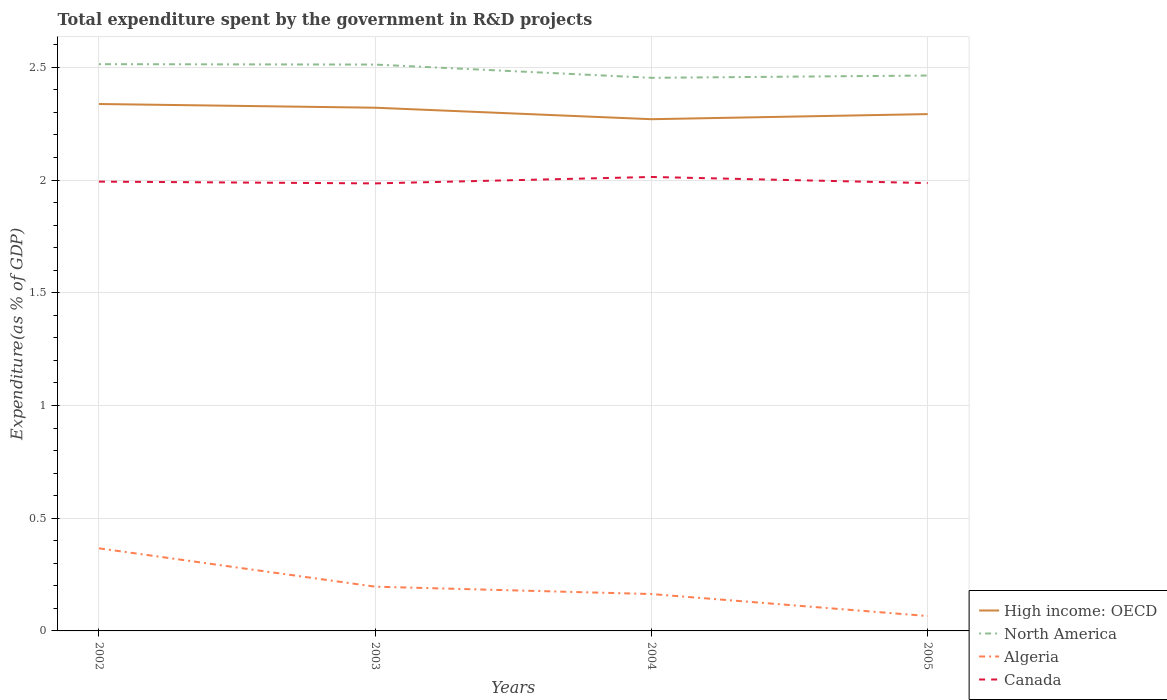How many different coloured lines are there?
Keep it short and to the point. 4. Across all years, what is the maximum total expenditure spent by the government in R&D projects in Canada?
Your answer should be very brief. 1.99. What is the total total expenditure spent by the government in R&D projects in Algeria in the graph?
Provide a short and direct response. 0.3. What is the difference between the highest and the second highest total expenditure spent by the government in R&D projects in Algeria?
Give a very brief answer. 0.3. What is the difference between the highest and the lowest total expenditure spent by the government in R&D projects in Algeria?
Your response must be concise. 1. How many lines are there?
Provide a short and direct response. 4. Where does the legend appear in the graph?
Your response must be concise. Bottom right. What is the title of the graph?
Your answer should be compact. Total expenditure spent by the government in R&D projects. Does "High income" appear as one of the legend labels in the graph?
Keep it short and to the point. No. What is the label or title of the X-axis?
Offer a terse response. Years. What is the label or title of the Y-axis?
Offer a terse response. Expenditure(as % of GDP). What is the Expenditure(as % of GDP) of High income: OECD in 2002?
Your answer should be compact. 2.34. What is the Expenditure(as % of GDP) of North America in 2002?
Your answer should be very brief. 2.51. What is the Expenditure(as % of GDP) in Algeria in 2002?
Offer a terse response. 0.37. What is the Expenditure(as % of GDP) in Canada in 2002?
Keep it short and to the point. 1.99. What is the Expenditure(as % of GDP) in High income: OECD in 2003?
Ensure brevity in your answer.  2.32. What is the Expenditure(as % of GDP) of North America in 2003?
Your answer should be very brief. 2.51. What is the Expenditure(as % of GDP) of Algeria in 2003?
Provide a succinct answer. 0.2. What is the Expenditure(as % of GDP) of Canada in 2003?
Give a very brief answer. 1.99. What is the Expenditure(as % of GDP) in High income: OECD in 2004?
Keep it short and to the point. 2.27. What is the Expenditure(as % of GDP) in North America in 2004?
Your answer should be very brief. 2.45. What is the Expenditure(as % of GDP) of Algeria in 2004?
Offer a terse response. 0.16. What is the Expenditure(as % of GDP) in Canada in 2004?
Your answer should be very brief. 2.01. What is the Expenditure(as % of GDP) in High income: OECD in 2005?
Make the answer very short. 2.29. What is the Expenditure(as % of GDP) of North America in 2005?
Your answer should be compact. 2.46. What is the Expenditure(as % of GDP) in Algeria in 2005?
Provide a succinct answer. 0.07. What is the Expenditure(as % of GDP) of Canada in 2005?
Your answer should be compact. 1.99. Across all years, what is the maximum Expenditure(as % of GDP) of High income: OECD?
Offer a very short reply. 2.34. Across all years, what is the maximum Expenditure(as % of GDP) in North America?
Give a very brief answer. 2.51. Across all years, what is the maximum Expenditure(as % of GDP) in Algeria?
Make the answer very short. 0.37. Across all years, what is the maximum Expenditure(as % of GDP) of Canada?
Keep it short and to the point. 2.01. Across all years, what is the minimum Expenditure(as % of GDP) of High income: OECD?
Your answer should be very brief. 2.27. Across all years, what is the minimum Expenditure(as % of GDP) in North America?
Ensure brevity in your answer.  2.45. Across all years, what is the minimum Expenditure(as % of GDP) in Algeria?
Give a very brief answer. 0.07. Across all years, what is the minimum Expenditure(as % of GDP) of Canada?
Keep it short and to the point. 1.99. What is the total Expenditure(as % of GDP) of High income: OECD in the graph?
Your answer should be compact. 9.22. What is the total Expenditure(as % of GDP) of North America in the graph?
Ensure brevity in your answer.  9.94. What is the total Expenditure(as % of GDP) of Algeria in the graph?
Your response must be concise. 0.79. What is the total Expenditure(as % of GDP) of Canada in the graph?
Provide a short and direct response. 7.98. What is the difference between the Expenditure(as % of GDP) in High income: OECD in 2002 and that in 2003?
Provide a succinct answer. 0.02. What is the difference between the Expenditure(as % of GDP) of North America in 2002 and that in 2003?
Your response must be concise. 0. What is the difference between the Expenditure(as % of GDP) in Algeria in 2002 and that in 2003?
Provide a succinct answer. 0.17. What is the difference between the Expenditure(as % of GDP) of Canada in 2002 and that in 2003?
Your answer should be compact. 0.01. What is the difference between the Expenditure(as % of GDP) in High income: OECD in 2002 and that in 2004?
Your answer should be very brief. 0.07. What is the difference between the Expenditure(as % of GDP) of North America in 2002 and that in 2004?
Make the answer very short. 0.06. What is the difference between the Expenditure(as % of GDP) of Algeria in 2002 and that in 2004?
Offer a very short reply. 0.2. What is the difference between the Expenditure(as % of GDP) of Canada in 2002 and that in 2004?
Provide a short and direct response. -0.02. What is the difference between the Expenditure(as % of GDP) in High income: OECD in 2002 and that in 2005?
Your answer should be compact. 0.04. What is the difference between the Expenditure(as % of GDP) of North America in 2002 and that in 2005?
Your answer should be compact. 0.05. What is the difference between the Expenditure(as % of GDP) of Algeria in 2002 and that in 2005?
Keep it short and to the point. 0.3. What is the difference between the Expenditure(as % of GDP) in Canada in 2002 and that in 2005?
Keep it short and to the point. 0.01. What is the difference between the Expenditure(as % of GDP) of High income: OECD in 2003 and that in 2004?
Your answer should be compact. 0.05. What is the difference between the Expenditure(as % of GDP) of North America in 2003 and that in 2004?
Your response must be concise. 0.06. What is the difference between the Expenditure(as % of GDP) of Algeria in 2003 and that in 2004?
Ensure brevity in your answer.  0.03. What is the difference between the Expenditure(as % of GDP) in Canada in 2003 and that in 2004?
Keep it short and to the point. -0.03. What is the difference between the Expenditure(as % of GDP) in High income: OECD in 2003 and that in 2005?
Ensure brevity in your answer.  0.03. What is the difference between the Expenditure(as % of GDP) in North America in 2003 and that in 2005?
Offer a terse response. 0.05. What is the difference between the Expenditure(as % of GDP) of Algeria in 2003 and that in 2005?
Offer a very short reply. 0.13. What is the difference between the Expenditure(as % of GDP) in Canada in 2003 and that in 2005?
Provide a short and direct response. -0. What is the difference between the Expenditure(as % of GDP) in High income: OECD in 2004 and that in 2005?
Make the answer very short. -0.02. What is the difference between the Expenditure(as % of GDP) of North America in 2004 and that in 2005?
Your answer should be compact. -0.01. What is the difference between the Expenditure(as % of GDP) in Algeria in 2004 and that in 2005?
Your answer should be very brief. 0.1. What is the difference between the Expenditure(as % of GDP) of Canada in 2004 and that in 2005?
Offer a terse response. 0.03. What is the difference between the Expenditure(as % of GDP) in High income: OECD in 2002 and the Expenditure(as % of GDP) in North America in 2003?
Provide a succinct answer. -0.17. What is the difference between the Expenditure(as % of GDP) in High income: OECD in 2002 and the Expenditure(as % of GDP) in Algeria in 2003?
Ensure brevity in your answer.  2.14. What is the difference between the Expenditure(as % of GDP) of High income: OECD in 2002 and the Expenditure(as % of GDP) of Canada in 2003?
Give a very brief answer. 0.35. What is the difference between the Expenditure(as % of GDP) of North America in 2002 and the Expenditure(as % of GDP) of Algeria in 2003?
Offer a terse response. 2.32. What is the difference between the Expenditure(as % of GDP) of North America in 2002 and the Expenditure(as % of GDP) of Canada in 2003?
Give a very brief answer. 0.53. What is the difference between the Expenditure(as % of GDP) of Algeria in 2002 and the Expenditure(as % of GDP) of Canada in 2003?
Provide a succinct answer. -1.62. What is the difference between the Expenditure(as % of GDP) of High income: OECD in 2002 and the Expenditure(as % of GDP) of North America in 2004?
Provide a succinct answer. -0.12. What is the difference between the Expenditure(as % of GDP) in High income: OECD in 2002 and the Expenditure(as % of GDP) in Algeria in 2004?
Offer a very short reply. 2.17. What is the difference between the Expenditure(as % of GDP) in High income: OECD in 2002 and the Expenditure(as % of GDP) in Canada in 2004?
Your answer should be compact. 0.32. What is the difference between the Expenditure(as % of GDP) in North America in 2002 and the Expenditure(as % of GDP) in Algeria in 2004?
Ensure brevity in your answer.  2.35. What is the difference between the Expenditure(as % of GDP) of North America in 2002 and the Expenditure(as % of GDP) of Canada in 2004?
Provide a succinct answer. 0.5. What is the difference between the Expenditure(as % of GDP) in Algeria in 2002 and the Expenditure(as % of GDP) in Canada in 2004?
Your answer should be very brief. -1.65. What is the difference between the Expenditure(as % of GDP) of High income: OECD in 2002 and the Expenditure(as % of GDP) of North America in 2005?
Provide a short and direct response. -0.13. What is the difference between the Expenditure(as % of GDP) of High income: OECD in 2002 and the Expenditure(as % of GDP) of Algeria in 2005?
Provide a short and direct response. 2.27. What is the difference between the Expenditure(as % of GDP) of High income: OECD in 2002 and the Expenditure(as % of GDP) of Canada in 2005?
Keep it short and to the point. 0.35. What is the difference between the Expenditure(as % of GDP) in North America in 2002 and the Expenditure(as % of GDP) in Algeria in 2005?
Keep it short and to the point. 2.45. What is the difference between the Expenditure(as % of GDP) of North America in 2002 and the Expenditure(as % of GDP) of Canada in 2005?
Keep it short and to the point. 0.53. What is the difference between the Expenditure(as % of GDP) in Algeria in 2002 and the Expenditure(as % of GDP) in Canada in 2005?
Keep it short and to the point. -1.62. What is the difference between the Expenditure(as % of GDP) of High income: OECD in 2003 and the Expenditure(as % of GDP) of North America in 2004?
Provide a short and direct response. -0.13. What is the difference between the Expenditure(as % of GDP) of High income: OECD in 2003 and the Expenditure(as % of GDP) of Algeria in 2004?
Give a very brief answer. 2.16. What is the difference between the Expenditure(as % of GDP) of High income: OECD in 2003 and the Expenditure(as % of GDP) of Canada in 2004?
Ensure brevity in your answer.  0.31. What is the difference between the Expenditure(as % of GDP) in North America in 2003 and the Expenditure(as % of GDP) in Algeria in 2004?
Offer a terse response. 2.35. What is the difference between the Expenditure(as % of GDP) of North America in 2003 and the Expenditure(as % of GDP) of Canada in 2004?
Your answer should be compact. 0.5. What is the difference between the Expenditure(as % of GDP) in Algeria in 2003 and the Expenditure(as % of GDP) in Canada in 2004?
Offer a very short reply. -1.82. What is the difference between the Expenditure(as % of GDP) of High income: OECD in 2003 and the Expenditure(as % of GDP) of North America in 2005?
Keep it short and to the point. -0.14. What is the difference between the Expenditure(as % of GDP) in High income: OECD in 2003 and the Expenditure(as % of GDP) in Algeria in 2005?
Your answer should be compact. 2.25. What is the difference between the Expenditure(as % of GDP) of High income: OECD in 2003 and the Expenditure(as % of GDP) of Canada in 2005?
Make the answer very short. 0.33. What is the difference between the Expenditure(as % of GDP) in North America in 2003 and the Expenditure(as % of GDP) in Algeria in 2005?
Provide a succinct answer. 2.45. What is the difference between the Expenditure(as % of GDP) in North America in 2003 and the Expenditure(as % of GDP) in Canada in 2005?
Your answer should be compact. 0.53. What is the difference between the Expenditure(as % of GDP) in Algeria in 2003 and the Expenditure(as % of GDP) in Canada in 2005?
Give a very brief answer. -1.79. What is the difference between the Expenditure(as % of GDP) of High income: OECD in 2004 and the Expenditure(as % of GDP) of North America in 2005?
Provide a short and direct response. -0.19. What is the difference between the Expenditure(as % of GDP) of High income: OECD in 2004 and the Expenditure(as % of GDP) of Algeria in 2005?
Give a very brief answer. 2.2. What is the difference between the Expenditure(as % of GDP) in High income: OECD in 2004 and the Expenditure(as % of GDP) in Canada in 2005?
Provide a short and direct response. 0.28. What is the difference between the Expenditure(as % of GDP) in North America in 2004 and the Expenditure(as % of GDP) in Algeria in 2005?
Your response must be concise. 2.39. What is the difference between the Expenditure(as % of GDP) in North America in 2004 and the Expenditure(as % of GDP) in Canada in 2005?
Provide a short and direct response. 0.47. What is the difference between the Expenditure(as % of GDP) of Algeria in 2004 and the Expenditure(as % of GDP) of Canada in 2005?
Keep it short and to the point. -1.82. What is the average Expenditure(as % of GDP) in High income: OECD per year?
Keep it short and to the point. 2.31. What is the average Expenditure(as % of GDP) in North America per year?
Offer a terse response. 2.49. What is the average Expenditure(as % of GDP) in Algeria per year?
Provide a succinct answer. 0.2. What is the average Expenditure(as % of GDP) in Canada per year?
Offer a terse response. 1.99. In the year 2002, what is the difference between the Expenditure(as % of GDP) of High income: OECD and Expenditure(as % of GDP) of North America?
Your answer should be very brief. -0.18. In the year 2002, what is the difference between the Expenditure(as % of GDP) in High income: OECD and Expenditure(as % of GDP) in Algeria?
Offer a terse response. 1.97. In the year 2002, what is the difference between the Expenditure(as % of GDP) in High income: OECD and Expenditure(as % of GDP) in Canada?
Offer a terse response. 0.34. In the year 2002, what is the difference between the Expenditure(as % of GDP) of North America and Expenditure(as % of GDP) of Algeria?
Your answer should be very brief. 2.15. In the year 2002, what is the difference between the Expenditure(as % of GDP) of North America and Expenditure(as % of GDP) of Canada?
Provide a short and direct response. 0.52. In the year 2002, what is the difference between the Expenditure(as % of GDP) of Algeria and Expenditure(as % of GDP) of Canada?
Ensure brevity in your answer.  -1.63. In the year 2003, what is the difference between the Expenditure(as % of GDP) in High income: OECD and Expenditure(as % of GDP) in North America?
Provide a short and direct response. -0.19. In the year 2003, what is the difference between the Expenditure(as % of GDP) of High income: OECD and Expenditure(as % of GDP) of Algeria?
Make the answer very short. 2.12. In the year 2003, what is the difference between the Expenditure(as % of GDP) of High income: OECD and Expenditure(as % of GDP) of Canada?
Offer a very short reply. 0.34. In the year 2003, what is the difference between the Expenditure(as % of GDP) in North America and Expenditure(as % of GDP) in Algeria?
Your response must be concise. 2.32. In the year 2003, what is the difference between the Expenditure(as % of GDP) in North America and Expenditure(as % of GDP) in Canada?
Offer a terse response. 0.53. In the year 2003, what is the difference between the Expenditure(as % of GDP) of Algeria and Expenditure(as % of GDP) of Canada?
Provide a succinct answer. -1.79. In the year 2004, what is the difference between the Expenditure(as % of GDP) of High income: OECD and Expenditure(as % of GDP) of North America?
Ensure brevity in your answer.  -0.18. In the year 2004, what is the difference between the Expenditure(as % of GDP) in High income: OECD and Expenditure(as % of GDP) in Algeria?
Ensure brevity in your answer.  2.11. In the year 2004, what is the difference between the Expenditure(as % of GDP) of High income: OECD and Expenditure(as % of GDP) of Canada?
Provide a succinct answer. 0.26. In the year 2004, what is the difference between the Expenditure(as % of GDP) of North America and Expenditure(as % of GDP) of Algeria?
Make the answer very short. 2.29. In the year 2004, what is the difference between the Expenditure(as % of GDP) of North America and Expenditure(as % of GDP) of Canada?
Ensure brevity in your answer.  0.44. In the year 2004, what is the difference between the Expenditure(as % of GDP) of Algeria and Expenditure(as % of GDP) of Canada?
Provide a short and direct response. -1.85. In the year 2005, what is the difference between the Expenditure(as % of GDP) in High income: OECD and Expenditure(as % of GDP) in North America?
Give a very brief answer. -0.17. In the year 2005, what is the difference between the Expenditure(as % of GDP) in High income: OECD and Expenditure(as % of GDP) in Algeria?
Offer a very short reply. 2.23. In the year 2005, what is the difference between the Expenditure(as % of GDP) in High income: OECD and Expenditure(as % of GDP) in Canada?
Keep it short and to the point. 0.31. In the year 2005, what is the difference between the Expenditure(as % of GDP) in North America and Expenditure(as % of GDP) in Algeria?
Ensure brevity in your answer.  2.4. In the year 2005, what is the difference between the Expenditure(as % of GDP) in North America and Expenditure(as % of GDP) in Canada?
Provide a succinct answer. 0.48. In the year 2005, what is the difference between the Expenditure(as % of GDP) in Algeria and Expenditure(as % of GDP) in Canada?
Your answer should be compact. -1.92. What is the ratio of the Expenditure(as % of GDP) of High income: OECD in 2002 to that in 2003?
Offer a terse response. 1.01. What is the ratio of the Expenditure(as % of GDP) of North America in 2002 to that in 2003?
Give a very brief answer. 1. What is the ratio of the Expenditure(as % of GDP) in Algeria in 2002 to that in 2003?
Provide a short and direct response. 1.87. What is the ratio of the Expenditure(as % of GDP) of High income: OECD in 2002 to that in 2004?
Your response must be concise. 1.03. What is the ratio of the Expenditure(as % of GDP) of North America in 2002 to that in 2004?
Your answer should be compact. 1.02. What is the ratio of the Expenditure(as % of GDP) of Algeria in 2002 to that in 2004?
Provide a short and direct response. 2.24. What is the ratio of the Expenditure(as % of GDP) in High income: OECD in 2002 to that in 2005?
Your response must be concise. 1.02. What is the ratio of the Expenditure(as % of GDP) in North America in 2002 to that in 2005?
Provide a short and direct response. 1.02. What is the ratio of the Expenditure(as % of GDP) in Algeria in 2002 to that in 2005?
Your answer should be very brief. 5.55. What is the ratio of the Expenditure(as % of GDP) in Canada in 2002 to that in 2005?
Your answer should be compact. 1. What is the ratio of the Expenditure(as % of GDP) in High income: OECD in 2003 to that in 2004?
Your answer should be compact. 1.02. What is the ratio of the Expenditure(as % of GDP) in North America in 2003 to that in 2004?
Your answer should be very brief. 1.02. What is the ratio of the Expenditure(as % of GDP) in Algeria in 2003 to that in 2004?
Your answer should be compact. 1.2. What is the ratio of the Expenditure(as % of GDP) in Canada in 2003 to that in 2004?
Your answer should be very brief. 0.99. What is the ratio of the Expenditure(as % of GDP) of High income: OECD in 2003 to that in 2005?
Your response must be concise. 1.01. What is the ratio of the Expenditure(as % of GDP) of North America in 2003 to that in 2005?
Provide a succinct answer. 1.02. What is the ratio of the Expenditure(as % of GDP) in Algeria in 2003 to that in 2005?
Your response must be concise. 2.97. What is the ratio of the Expenditure(as % of GDP) in Canada in 2003 to that in 2005?
Offer a very short reply. 1. What is the ratio of the Expenditure(as % of GDP) in North America in 2004 to that in 2005?
Offer a very short reply. 1. What is the ratio of the Expenditure(as % of GDP) in Algeria in 2004 to that in 2005?
Your response must be concise. 2.48. What is the ratio of the Expenditure(as % of GDP) in Canada in 2004 to that in 2005?
Offer a terse response. 1.01. What is the difference between the highest and the second highest Expenditure(as % of GDP) of High income: OECD?
Ensure brevity in your answer.  0.02. What is the difference between the highest and the second highest Expenditure(as % of GDP) in North America?
Offer a terse response. 0. What is the difference between the highest and the second highest Expenditure(as % of GDP) of Algeria?
Your response must be concise. 0.17. What is the difference between the highest and the second highest Expenditure(as % of GDP) of Canada?
Your answer should be very brief. 0.02. What is the difference between the highest and the lowest Expenditure(as % of GDP) in High income: OECD?
Provide a short and direct response. 0.07. What is the difference between the highest and the lowest Expenditure(as % of GDP) in North America?
Keep it short and to the point. 0.06. What is the difference between the highest and the lowest Expenditure(as % of GDP) of Algeria?
Your response must be concise. 0.3. What is the difference between the highest and the lowest Expenditure(as % of GDP) in Canada?
Provide a short and direct response. 0.03. 